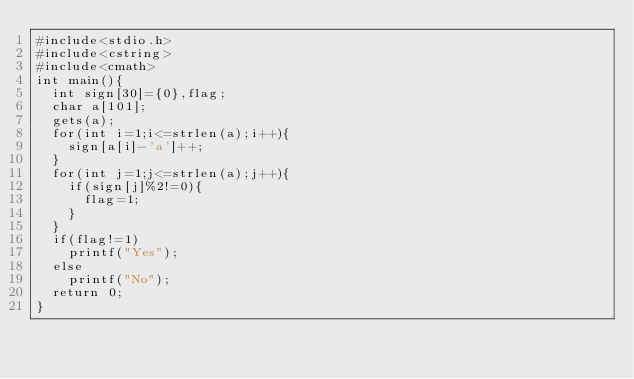Convert code to text. <code><loc_0><loc_0><loc_500><loc_500><_C++_>#include<stdio.h>
#include<cstring>
#include<cmath>
int main(){
	int sign[30]={0},flag;
	char a[101];
	gets(a);
	for(int i=1;i<=strlen(a);i++){
		sign[a[i]-'a']++;
	}
	for(int j=1;j<=strlen(a);j++){
		if(sign[j]%2!=0){
			flag=1;
		}
	} 
	if(flag!=1)
		printf("Yes");
	else
		printf("No");
	return 0;
}</code> 